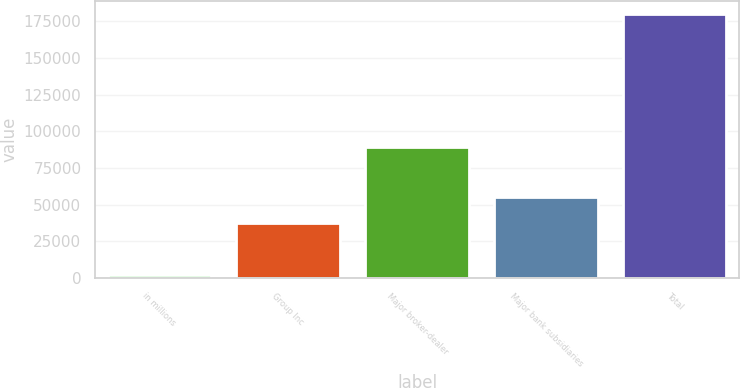Convert chart. <chart><loc_0><loc_0><loc_500><loc_500><bar_chart><fcel>in millions<fcel>Group Inc<fcel>Major broker-dealer<fcel>Major bank subsidiaries<fcel>Total<nl><fcel>2014<fcel>37699<fcel>89549<fcel>55460.9<fcel>179633<nl></chart> 